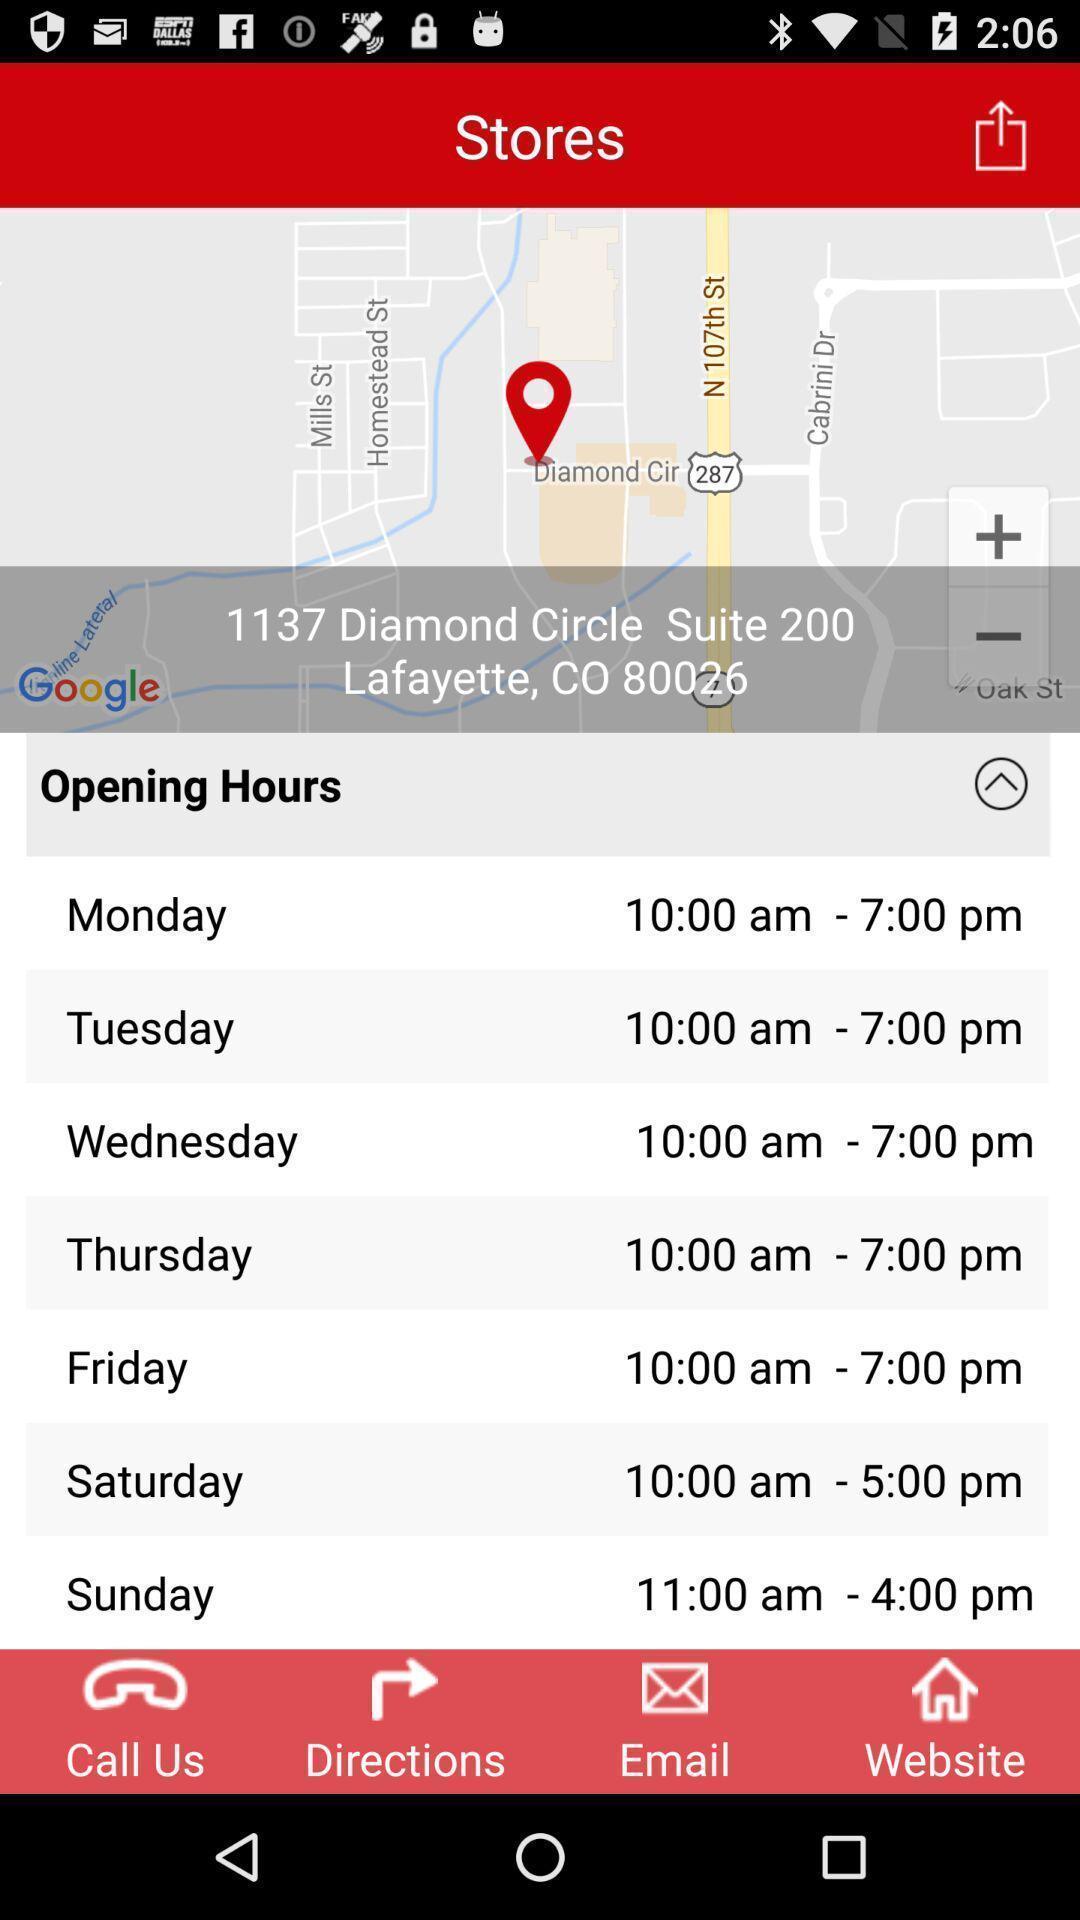What details can you identify in this image? Screen showing stores opening hours. 